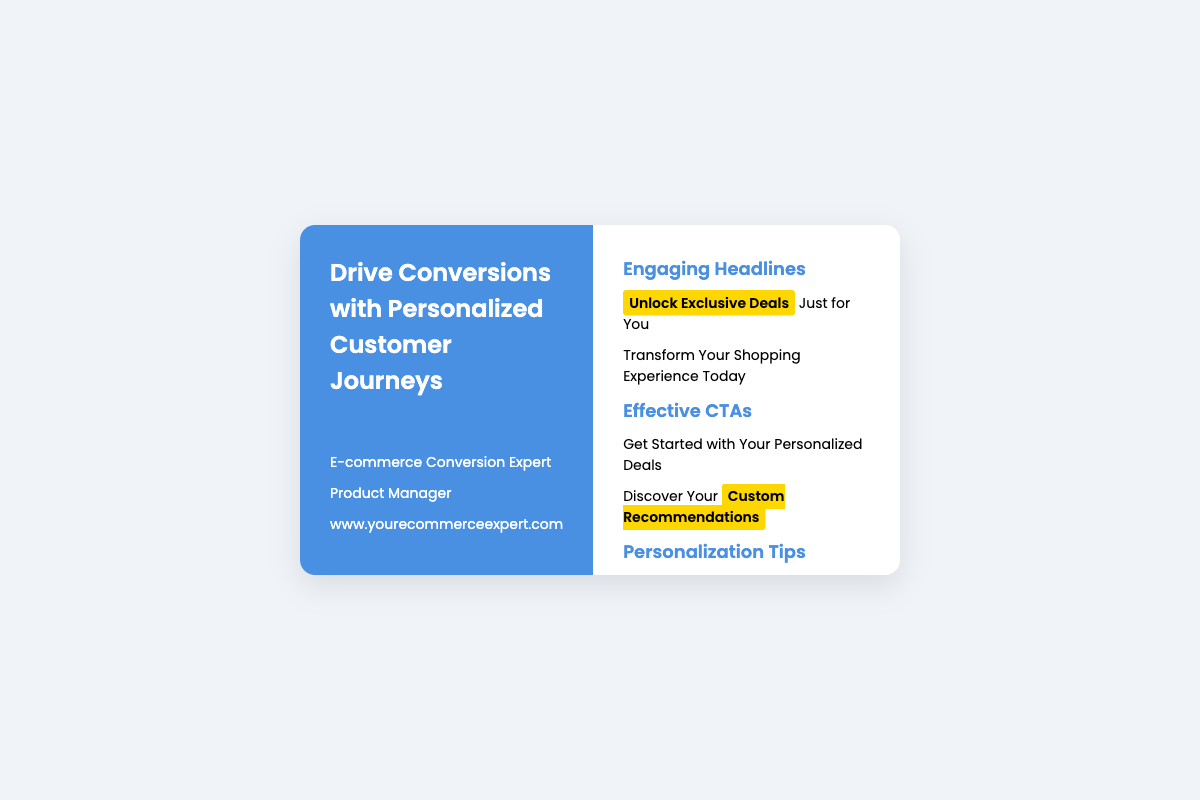What is the title of the business card? The title of the business card is prominently displayed at the top section, which presents the main service offering of the individual.
Answer: Drive Conversions with Personalized Customer Journeys Who is the target professional role mentioned? The document specifies the role of the individual, indicating their expertise and position related to e-commerce.
Answer: Product Manager What website is listed on the card? The document includes a web address under the professional information part for potential contact or further information.
Answer: www.yourecommerceexpert.com What is one engaging headline mentioned? One of the engaging headlines is highlighted in the right section, emphasizing exclusive offers to the customer.
Answer: Unlock Exclusive Deals What is one of the personalization tips provided? The document includes a section specifically for tips, showcasing strategies for improving customer journeys.
Answer: Segment User Data How many sections are there for CTAs? The business card contains specific sections dedicated to Calls to Action, reflecting the main strategies to prompt user engagement.
Answer: Two What color is used for the left side of the business card? The left side of the card features a certain color, creating a visual distinction and appeal.
Answer: Blue What is the main message in the footer? The footer encapsulates the overall intent of the business card, summarizing the service provided.
Answer: Boost your e-commerce conversions with well-crafted, personalized customer journeys 